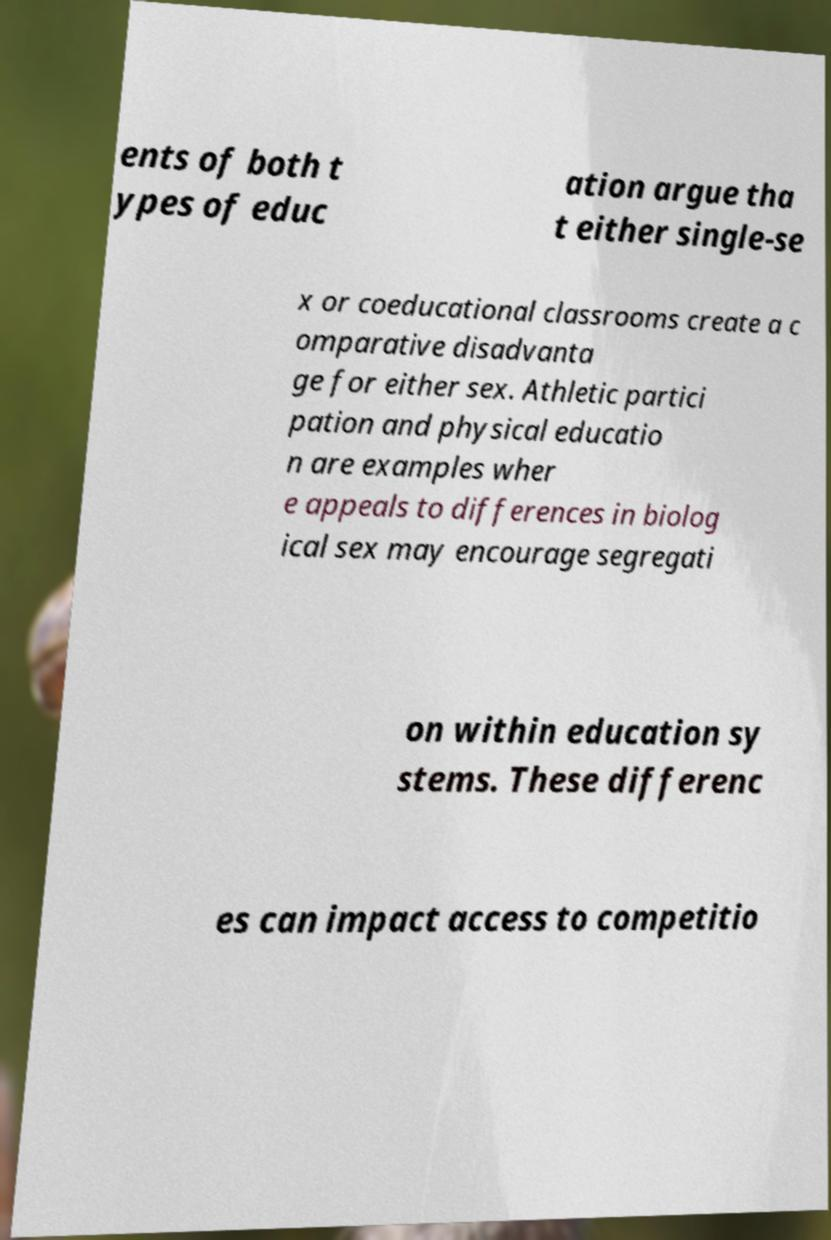Please read and relay the text visible in this image. What does it say? ents of both t ypes of educ ation argue tha t either single-se x or coeducational classrooms create a c omparative disadvanta ge for either sex. Athletic partici pation and physical educatio n are examples wher e appeals to differences in biolog ical sex may encourage segregati on within education sy stems. These differenc es can impact access to competitio 